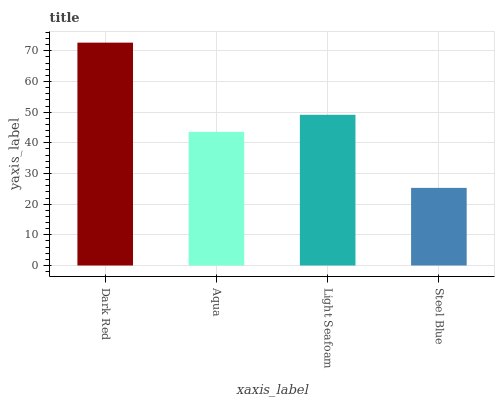Is Steel Blue the minimum?
Answer yes or no. Yes. Is Dark Red the maximum?
Answer yes or no. Yes. Is Aqua the minimum?
Answer yes or no. No. Is Aqua the maximum?
Answer yes or no. No. Is Dark Red greater than Aqua?
Answer yes or no. Yes. Is Aqua less than Dark Red?
Answer yes or no. Yes. Is Aqua greater than Dark Red?
Answer yes or no. No. Is Dark Red less than Aqua?
Answer yes or no. No. Is Light Seafoam the high median?
Answer yes or no. Yes. Is Aqua the low median?
Answer yes or no. Yes. Is Dark Red the high median?
Answer yes or no. No. Is Dark Red the low median?
Answer yes or no. No. 